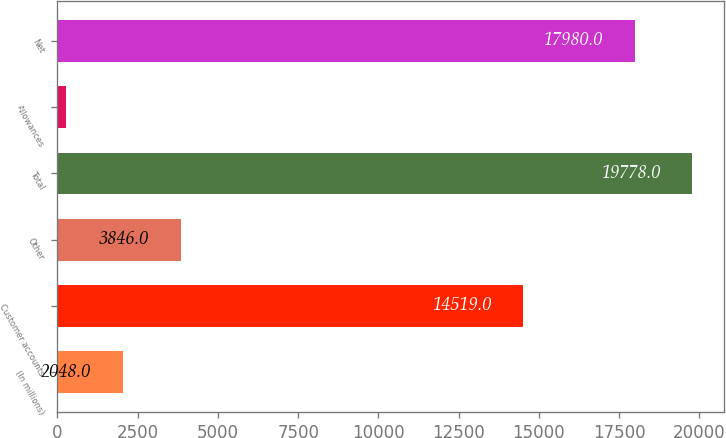<chart> <loc_0><loc_0><loc_500><loc_500><bar_chart><fcel>(In millions)<fcel>Customer accounts<fcel>Other<fcel>Total<fcel>Allowances<fcel>Net<nl><fcel>2048<fcel>14519<fcel>3846<fcel>19778<fcel>250<fcel>17980<nl></chart> 